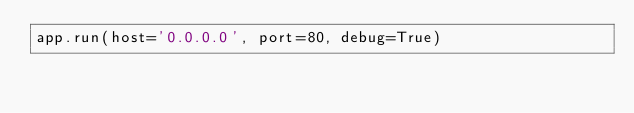<code> <loc_0><loc_0><loc_500><loc_500><_Python_>app.run(host='0.0.0.0', port=80, debug=True)</code> 